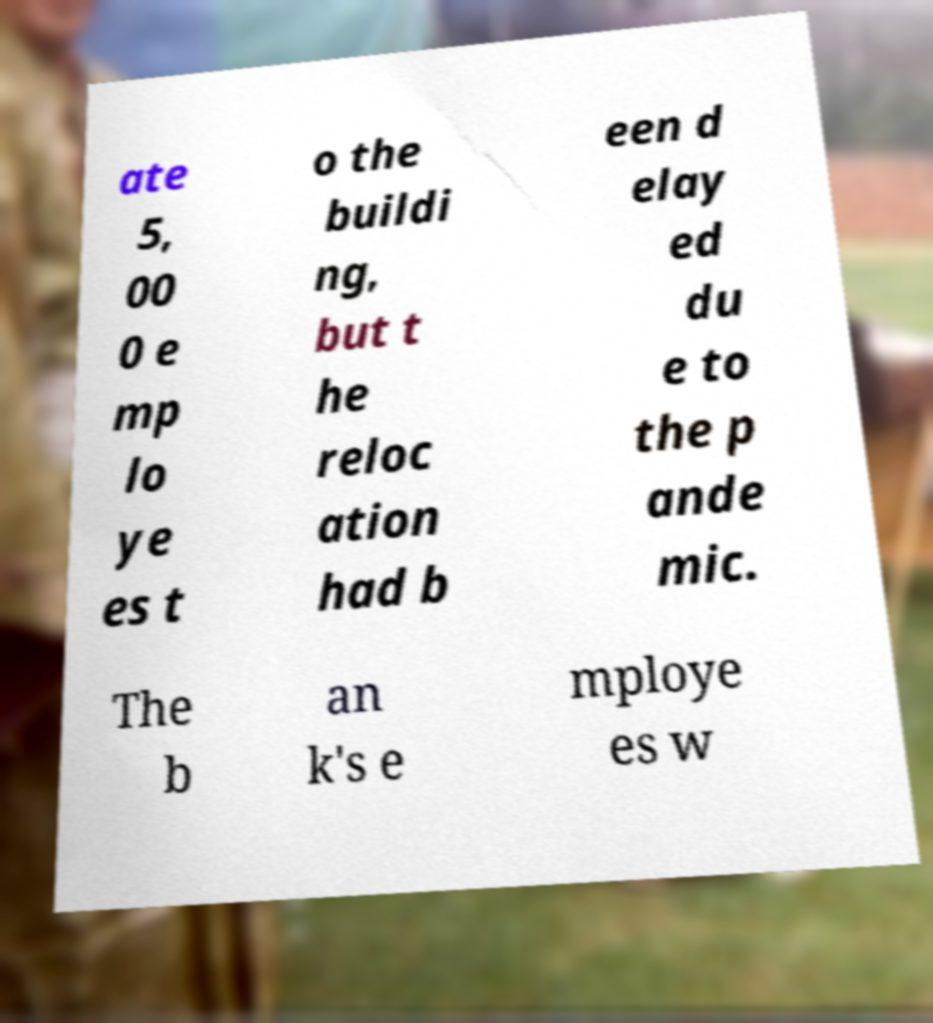Could you assist in decoding the text presented in this image and type it out clearly? ate 5, 00 0 e mp lo ye es t o the buildi ng, but t he reloc ation had b een d elay ed du e to the p ande mic. The b an k's e mploye es w 